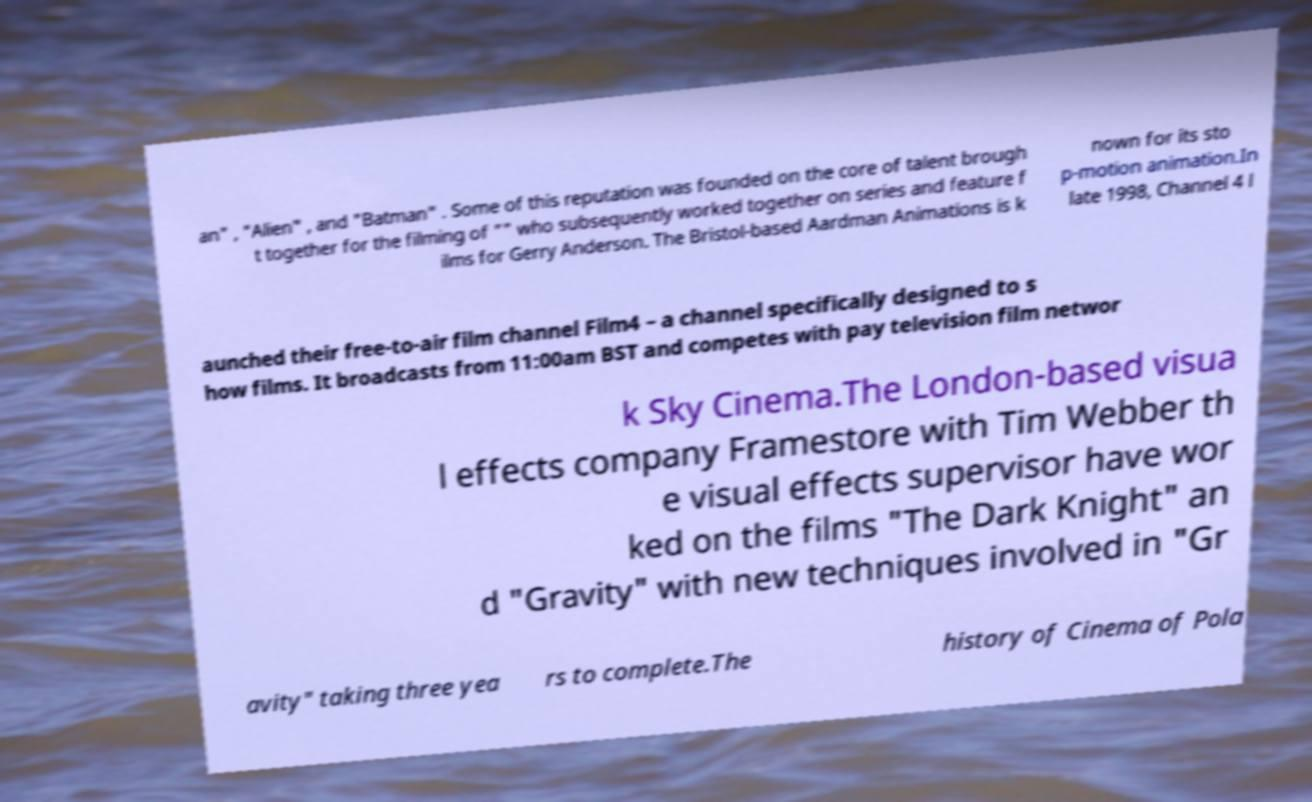Could you extract and type out the text from this image? an" , "Alien" , and "Batman" . Some of this reputation was founded on the core of talent brough t together for the filming of "" who subsequently worked together on series and feature f ilms for Gerry Anderson. The Bristol-based Aardman Animations is k nown for its sto p-motion animation.In late 1998, Channel 4 l aunched their free-to-air film channel Film4 – a channel specifically designed to s how films. It broadcasts from 11:00am BST and competes with pay television film networ k Sky Cinema.The London-based visua l effects company Framestore with Tim Webber th e visual effects supervisor have wor ked on the films "The Dark Knight" an d "Gravity" with new techniques involved in "Gr avity" taking three yea rs to complete.The history of Cinema of Pola 